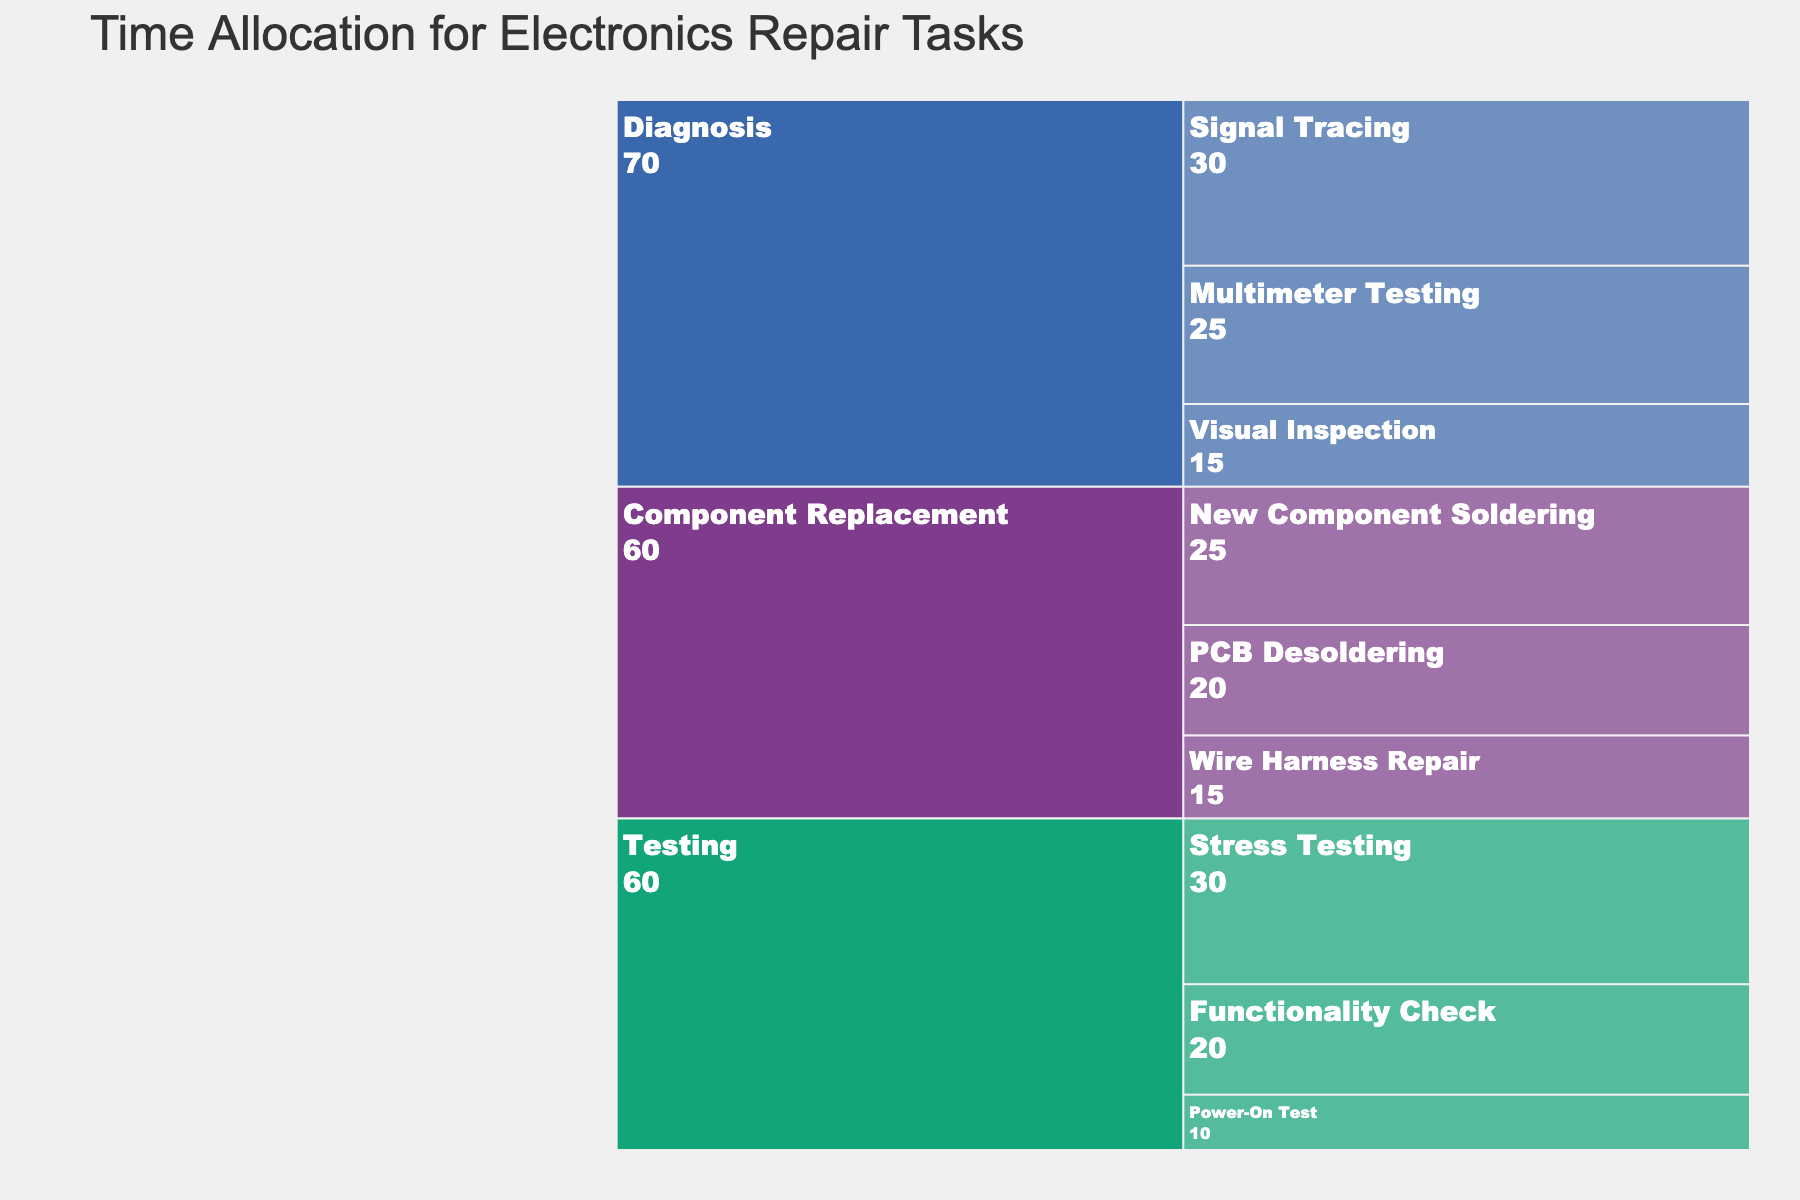What's the title of the figure? The title is usually displayed at the top of the figure and provides a summary of the chart's content.
Answer: Time Allocation for Electronics Repair Tasks What is the phase with the highest allocated time? Add up the time for all the subtasks within each phase. Diagnosis: 15+25+30, Component Replacement: 20+25+15, Testing: 10+20+30. Compare the totals: Diagnosis = 70, Component Replacement = 60, Testing = 60.
Answer: Diagnosis How much time is allocated to multimeter testing? Locate the "Multimeter Testing" subtask under the "Diagnosis" phase and read the corresponding time value.
Answer: 25 minutes What is the total time allocated for component replacement tasks? Add up the time for the subtasks under the "Component Replacement" phase: PCB Desoldering (20) + New Component Soldering (25) + Wire Harness Repair (15).
Answer: 60 minutes Which phase has the least allocated time and what is the total? Identify the phase with the smallest sum of its subtask times: Diagnosis = 70, Component Replacement = 60, Testing = 60. The testing phase has the sum of 60, as does Component Replacement, so neither is the least. This results in a tie.
Answer: Component Replacement and Testing with 60 minutes Which subtask within the Diagnosis phase takes the most time, and how much? Compare the subtasks under the Diagnosis phase: Visual Inspection (15), Multimeter Testing (25), Signal Tracing (30). Signal Tracing takes the most time.
Answer: Signal Tracing, 30 minutes What is the combined time for all Testing-related tasks? Sum the times for the subtasks under the "Testing" phase: Power-On Test (10) + Functionality Check (20) + Stress Testing (30).
Answer: 60 minutes Between "Visual Inspection" and "Functionality Check," which subtask takes more time and by how much? Compare the times for both subtasks: Visual Inspection (15), Functionality Check (20). The difference is 20 - 15.
Answer: Functionality Check by 5 minutes How does the total time for "PCB Desoldering" and "New Component Soldering" compare to the total for the entire Testing phase? Sum the times for PCB Desoldering (20) and New Component Soldering (25): 20 + 25 = 45. Compare it with the total for Testing: 10+20+30 = 60.
Answer: Less by 15 minutes 